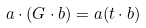<formula> <loc_0><loc_0><loc_500><loc_500>a \cdot ( G \cdot b ) = a ( t \cdot b )</formula> 